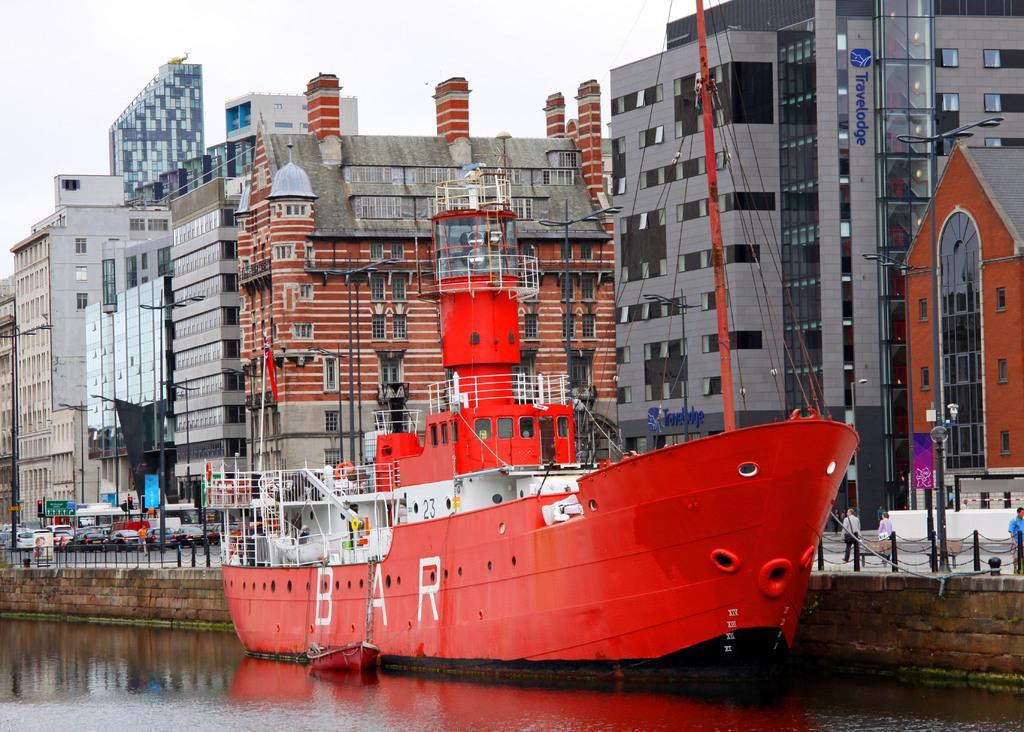Please provide a concise description of this image. In this image we can see few buildings. Few cars are waiting near a traffic signal and few people are walking at the bottom of the image. 